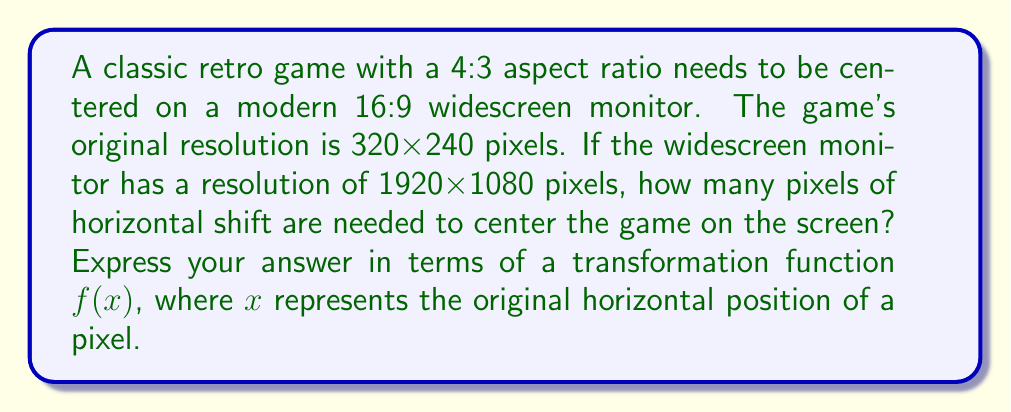Can you solve this math problem? To solve this problem, we need to follow these steps:

1) First, let's calculate the scaling factor to fit the retro game vertically on the widescreen monitor:
   
   $\text{Scaling factor} = \frac{1080}{240} = 4.5$

2) Now, let's calculate the width of the scaled retro game:
   
   $320 \times 4.5 = 1440$ pixels

3) The remaining horizontal space on the widescreen monitor is:
   
   $1920 - 1440 = 480$ pixels

4) To center the game, we need to shift it by half of this remaining space:
   
   $480 \div 2 = 240$ pixels

5) The horizontal shift transformation can be represented as:

   $f(x) = x + 240$

   Where $x$ is the original horizontal position of a pixel in the retro game, and $f(x)$ is its new position on the widescreen monitor.

This transformation shifts every point of the retro game 240 pixels to the right, effectively centering it on the widescreen display.
Answer: $f(x) = x + 240$ 